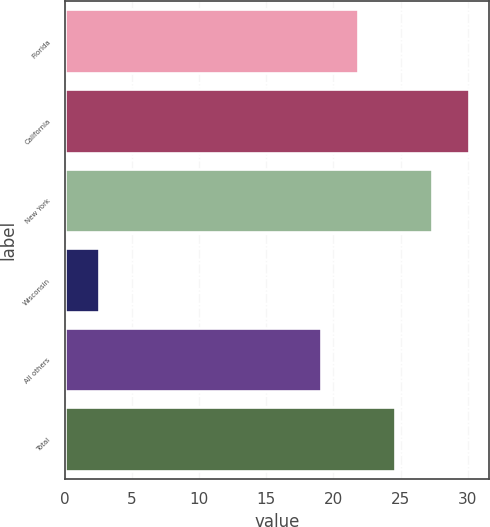<chart> <loc_0><loc_0><loc_500><loc_500><bar_chart><fcel>Florida<fcel>California<fcel>New York<fcel>Wisconsin<fcel>All others<fcel>Total<nl><fcel>21.83<fcel>30.11<fcel>27.35<fcel>2.54<fcel>19.07<fcel>24.59<nl></chart> 